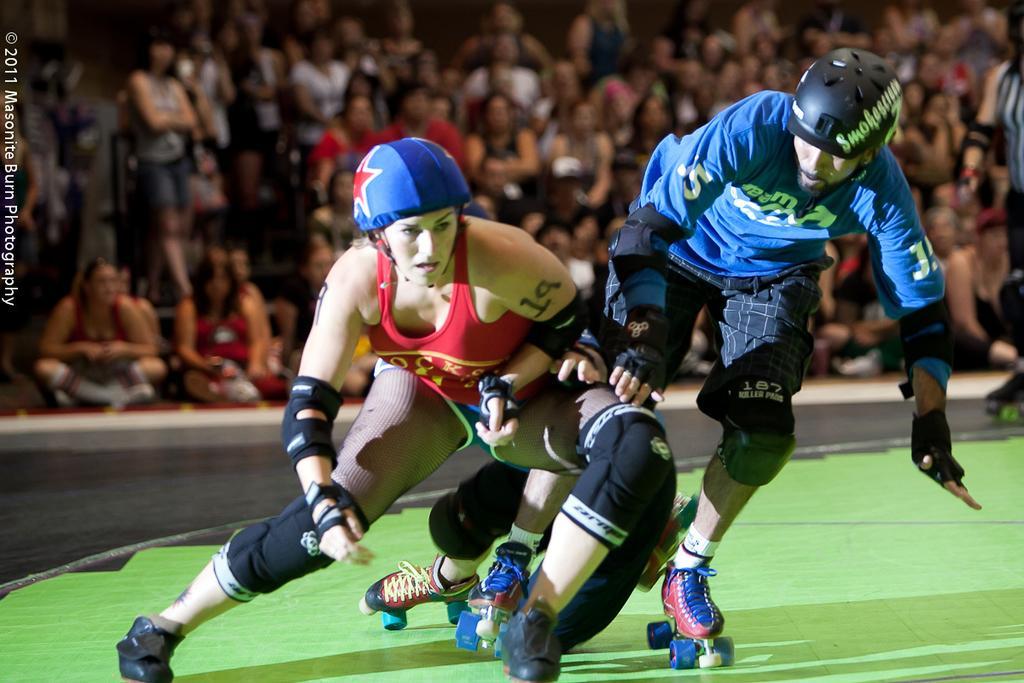How would you summarize this image in a sentence or two? In this picture, it seems like people skating in the foreground area of the image, there are other people sitting in the background. 